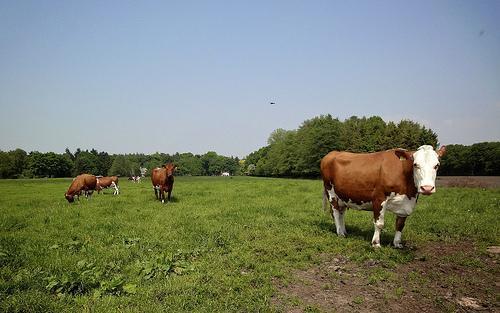How many cows are there?
Give a very brief answer. 5. How many cows are eating?
Give a very brief answer. 1. 